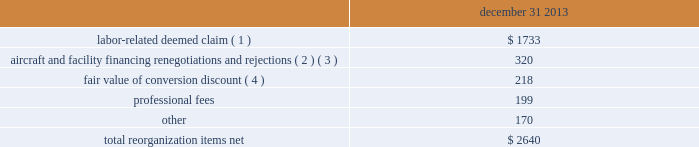Table of contents notes to consolidated financial statements of american airlines , inc .
Certificate of incorporation ( the certificate of incorporation ) contains transfer restrictions applicable to certain substantial stockholders .
Although the purpose of these transfer restrictions is to prevent an ownership change from occurring , there can be no assurance that an ownership change will not occur even with these transfer restrictions .
A copy of the certificate of incorporation was attached as exhibit 3.1 to a current report on form 8-k filed by aag with the sec on december 9 , 2013 .
Reorganization items , net reorganization items refer to revenues , expenses ( including professional fees ) , realized gains and losses and provisions for losses that are realized or incurred in the chapter 11 cases .
The table summarizes the components included in reorganization items , net on the consolidated statement of operations for the year ended december 31 , 2013 ( in millions ) : december 31 .
( 1 ) in exchange for employees 2019 contributions to the successful reorganization , including agreeing to reductions in pay and benefits , american agreed in the plan to provide each employee group a deemed claim , which was used to provide a distribution of a portion of the equity of the reorganized entity to those employees .
Each employee group received a deemed claim amount based upon a portion of the value of cost savings provided by that group through reductions to pay and benefits as well as through certain work rule changes .
The total value of this deemed claim was approximately $ 1.7 billion .
( 2 ) amounts include allowed claims ( claims approved by the bankruptcy court ) and estimated allowed claims relating to ( i ) the rejection or modification of financings related to aircraft and ( ii ) entry of orders treated as unsecured claims with respect to facility agreements supporting certain issuances of special facility revenue bonds .
The debtors recorded an estimated claim associated with the rejection or modification of a financing or facility agreement when the applicable motion was filed with the bankruptcy court to reject or modify such financing or facility agreement and the debtors believed that it was probable the motion would be approved , and there was sufficient information to estimate the claim .
( 3 ) pursuant to the plan , the debtors agreed to allow certain post-petition unsecured claims on obligations .
As a result , during the year ended december 31 , 2013 , american recorded reorganization charges to adjust estimated allowed claim amounts previously recorded on rejected special facility revenue bonds of $ 180 million , allowed general unsecured claims related to the 1990 and 1994 series of special facility revenue bonds that financed certain improvements at john f .
Kennedy international airport ( jfk ) , and rejected bonds that financed certain improvements at chicago o 2019hare international airport ( ord ) , which are included in the table above .
( 4 ) the plan allowed unsecured creditors receiving aag series a preferred stock a conversion discount of 3.5% ( 3.5 % ) .
Accordingly , american recorded the fair value of such discount upon the confirmation of the plan by the bankruptcy court. .
What is the ratio of the professional fees to the other fees? 
Rationale: there is $ 1.2 of professional fees for every $ 1 of other fees
Computations: (1990 / 170)
Answer: 11.70588. 